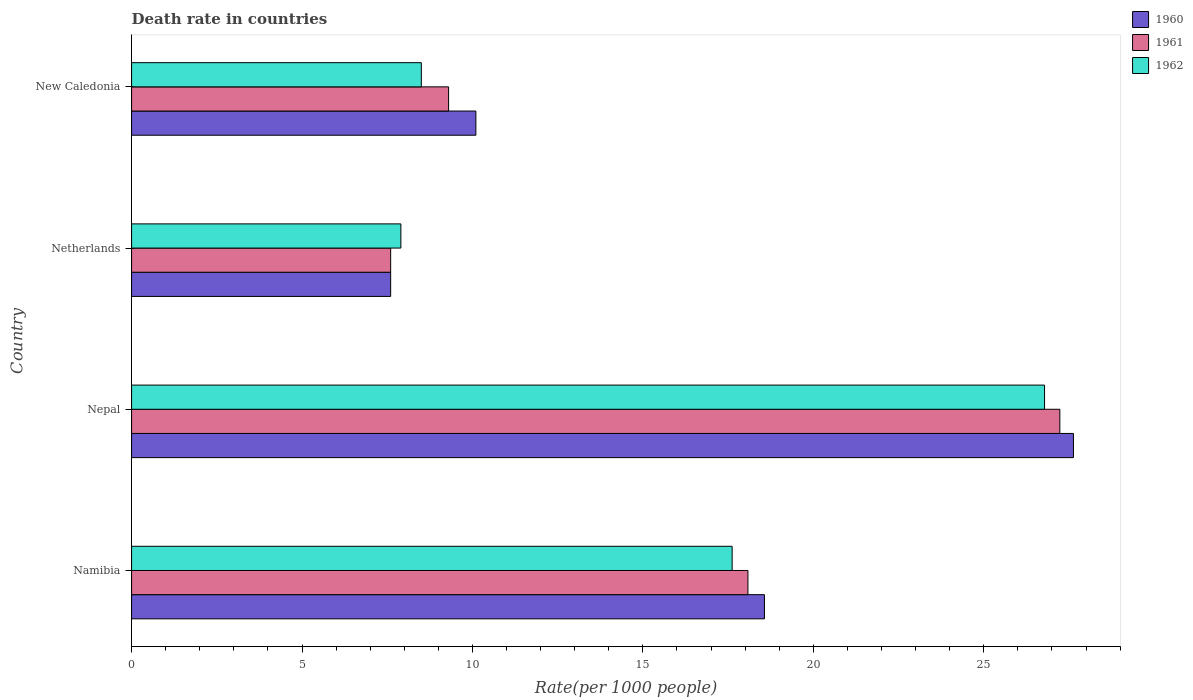How many different coloured bars are there?
Offer a very short reply. 3. How many groups of bars are there?
Your answer should be compact. 4. Are the number of bars per tick equal to the number of legend labels?
Offer a terse response. Yes. Are the number of bars on each tick of the Y-axis equal?
Provide a short and direct response. Yes. How many bars are there on the 1st tick from the bottom?
Make the answer very short. 3. What is the label of the 4th group of bars from the top?
Offer a very short reply. Namibia. In how many cases, is the number of bars for a given country not equal to the number of legend labels?
Offer a terse response. 0. What is the death rate in 1960 in Nepal?
Ensure brevity in your answer.  27.63. Across all countries, what is the maximum death rate in 1962?
Keep it short and to the point. 26.78. Across all countries, what is the minimum death rate in 1961?
Your answer should be compact. 7.6. In which country was the death rate in 1961 maximum?
Offer a terse response. Nepal. What is the total death rate in 1961 in the graph?
Provide a short and direct response. 62.21. What is the difference between the death rate in 1961 in Nepal and that in New Caledonia?
Offer a very short reply. 17.93. What is the difference between the death rate in 1962 in Netherlands and the death rate in 1960 in New Caledonia?
Provide a succinct answer. -2.2. What is the average death rate in 1962 per country?
Make the answer very short. 15.2. What is the difference between the death rate in 1961 and death rate in 1962 in Namibia?
Your answer should be very brief. 0.46. In how many countries, is the death rate in 1962 greater than 24 ?
Your answer should be compact. 1. What is the ratio of the death rate in 1962 in Nepal to that in Netherlands?
Your answer should be very brief. 3.39. Is the death rate in 1960 in Namibia less than that in Netherlands?
Your response must be concise. No. What is the difference between the highest and the second highest death rate in 1961?
Provide a short and direct response. 9.15. What is the difference between the highest and the lowest death rate in 1960?
Provide a succinct answer. 20.03. In how many countries, is the death rate in 1962 greater than the average death rate in 1962 taken over all countries?
Your answer should be very brief. 2. What does the 1st bar from the top in Nepal represents?
Your answer should be compact. 1962. Is it the case that in every country, the sum of the death rate in 1962 and death rate in 1961 is greater than the death rate in 1960?
Make the answer very short. Yes. Are all the bars in the graph horizontal?
Provide a short and direct response. Yes. What is the title of the graph?
Give a very brief answer. Death rate in countries. What is the label or title of the X-axis?
Keep it short and to the point. Rate(per 1000 people). What is the label or title of the Y-axis?
Your answer should be very brief. Country. What is the Rate(per 1000 people) of 1960 in Namibia?
Provide a short and direct response. 18.57. What is the Rate(per 1000 people) of 1961 in Namibia?
Your answer should be compact. 18.08. What is the Rate(per 1000 people) of 1962 in Namibia?
Keep it short and to the point. 17.62. What is the Rate(per 1000 people) of 1960 in Nepal?
Give a very brief answer. 27.63. What is the Rate(per 1000 people) in 1961 in Nepal?
Provide a short and direct response. 27.23. What is the Rate(per 1000 people) of 1962 in Nepal?
Keep it short and to the point. 26.78. What is the Rate(per 1000 people) in 1960 in Netherlands?
Provide a succinct answer. 7.6. What is the Rate(per 1000 people) in 1961 in Netherlands?
Offer a terse response. 7.6. What is the Rate(per 1000 people) in 1961 in New Caledonia?
Your response must be concise. 9.3. Across all countries, what is the maximum Rate(per 1000 people) in 1960?
Give a very brief answer. 27.63. Across all countries, what is the maximum Rate(per 1000 people) in 1961?
Your response must be concise. 27.23. Across all countries, what is the maximum Rate(per 1000 people) in 1962?
Your answer should be very brief. 26.78. Across all countries, what is the minimum Rate(per 1000 people) of 1962?
Your answer should be compact. 7.9. What is the total Rate(per 1000 people) of 1960 in the graph?
Offer a terse response. 63.9. What is the total Rate(per 1000 people) of 1961 in the graph?
Provide a succinct answer. 62.21. What is the total Rate(per 1000 people) in 1962 in the graph?
Give a very brief answer. 60.8. What is the difference between the Rate(per 1000 people) in 1960 in Namibia and that in Nepal?
Keep it short and to the point. -9.06. What is the difference between the Rate(per 1000 people) in 1961 in Namibia and that in Nepal?
Your response must be concise. -9.15. What is the difference between the Rate(per 1000 people) of 1962 in Namibia and that in Nepal?
Your answer should be very brief. -9.16. What is the difference between the Rate(per 1000 people) in 1960 in Namibia and that in Netherlands?
Offer a terse response. 10.97. What is the difference between the Rate(per 1000 people) in 1961 in Namibia and that in Netherlands?
Give a very brief answer. 10.48. What is the difference between the Rate(per 1000 people) in 1962 in Namibia and that in Netherlands?
Your answer should be compact. 9.72. What is the difference between the Rate(per 1000 people) in 1960 in Namibia and that in New Caledonia?
Keep it short and to the point. 8.47. What is the difference between the Rate(per 1000 people) of 1961 in Namibia and that in New Caledonia?
Give a very brief answer. 8.78. What is the difference between the Rate(per 1000 people) of 1962 in Namibia and that in New Caledonia?
Your answer should be very brief. 9.12. What is the difference between the Rate(per 1000 people) of 1960 in Nepal and that in Netherlands?
Keep it short and to the point. 20.03. What is the difference between the Rate(per 1000 people) of 1961 in Nepal and that in Netherlands?
Make the answer very short. 19.63. What is the difference between the Rate(per 1000 people) of 1962 in Nepal and that in Netherlands?
Provide a short and direct response. 18.88. What is the difference between the Rate(per 1000 people) in 1960 in Nepal and that in New Caledonia?
Provide a succinct answer. 17.53. What is the difference between the Rate(per 1000 people) of 1961 in Nepal and that in New Caledonia?
Your answer should be very brief. 17.93. What is the difference between the Rate(per 1000 people) of 1962 in Nepal and that in New Caledonia?
Your response must be concise. 18.28. What is the difference between the Rate(per 1000 people) in 1962 in Netherlands and that in New Caledonia?
Offer a very short reply. -0.6. What is the difference between the Rate(per 1000 people) in 1960 in Namibia and the Rate(per 1000 people) in 1961 in Nepal?
Your answer should be very brief. -8.66. What is the difference between the Rate(per 1000 people) in 1960 in Namibia and the Rate(per 1000 people) in 1962 in Nepal?
Keep it short and to the point. -8.22. What is the difference between the Rate(per 1000 people) in 1961 in Namibia and the Rate(per 1000 people) in 1962 in Nepal?
Give a very brief answer. -8.7. What is the difference between the Rate(per 1000 people) of 1960 in Namibia and the Rate(per 1000 people) of 1961 in Netherlands?
Your answer should be compact. 10.97. What is the difference between the Rate(per 1000 people) in 1960 in Namibia and the Rate(per 1000 people) in 1962 in Netherlands?
Offer a terse response. 10.67. What is the difference between the Rate(per 1000 people) in 1961 in Namibia and the Rate(per 1000 people) in 1962 in Netherlands?
Ensure brevity in your answer.  10.18. What is the difference between the Rate(per 1000 people) of 1960 in Namibia and the Rate(per 1000 people) of 1961 in New Caledonia?
Make the answer very short. 9.27. What is the difference between the Rate(per 1000 people) in 1960 in Namibia and the Rate(per 1000 people) in 1962 in New Caledonia?
Ensure brevity in your answer.  10.07. What is the difference between the Rate(per 1000 people) in 1961 in Namibia and the Rate(per 1000 people) in 1962 in New Caledonia?
Your answer should be very brief. 9.58. What is the difference between the Rate(per 1000 people) of 1960 in Nepal and the Rate(per 1000 people) of 1961 in Netherlands?
Provide a short and direct response. 20.03. What is the difference between the Rate(per 1000 people) of 1960 in Nepal and the Rate(per 1000 people) of 1962 in Netherlands?
Your answer should be compact. 19.73. What is the difference between the Rate(per 1000 people) of 1961 in Nepal and the Rate(per 1000 people) of 1962 in Netherlands?
Provide a succinct answer. 19.33. What is the difference between the Rate(per 1000 people) in 1960 in Nepal and the Rate(per 1000 people) in 1961 in New Caledonia?
Your answer should be compact. 18.33. What is the difference between the Rate(per 1000 people) in 1960 in Nepal and the Rate(per 1000 people) in 1962 in New Caledonia?
Provide a succinct answer. 19.13. What is the difference between the Rate(per 1000 people) of 1961 in Nepal and the Rate(per 1000 people) of 1962 in New Caledonia?
Your answer should be compact. 18.73. What is the difference between the Rate(per 1000 people) in 1960 in Netherlands and the Rate(per 1000 people) in 1961 in New Caledonia?
Provide a succinct answer. -1.7. What is the difference between the Rate(per 1000 people) in 1961 in Netherlands and the Rate(per 1000 people) in 1962 in New Caledonia?
Your response must be concise. -0.9. What is the average Rate(per 1000 people) of 1960 per country?
Give a very brief answer. 15.97. What is the average Rate(per 1000 people) in 1961 per country?
Offer a terse response. 15.55. What is the average Rate(per 1000 people) of 1962 per country?
Ensure brevity in your answer.  15.2. What is the difference between the Rate(per 1000 people) of 1960 and Rate(per 1000 people) of 1961 in Namibia?
Offer a very short reply. 0.48. What is the difference between the Rate(per 1000 people) of 1960 and Rate(per 1000 people) of 1962 in Namibia?
Keep it short and to the point. 0.95. What is the difference between the Rate(per 1000 people) in 1961 and Rate(per 1000 people) in 1962 in Namibia?
Your response must be concise. 0.46. What is the difference between the Rate(per 1000 people) in 1960 and Rate(per 1000 people) in 1962 in Nepal?
Your answer should be compact. 0.85. What is the difference between the Rate(per 1000 people) in 1961 and Rate(per 1000 people) in 1962 in Nepal?
Ensure brevity in your answer.  0.45. What is the difference between the Rate(per 1000 people) of 1960 and Rate(per 1000 people) of 1961 in Netherlands?
Offer a very short reply. 0. What is the difference between the Rate(per 1000 people) in 1961 and Rate(per 1000 people) in 1962 in Netherlands?
Give a very brief answer. -0.3. What is the difference between the Rate(per 1000 people) in 1961 and Rate(per 1000 people) in 1962 in New Caledonia?
Your answer should be very brief. 0.8. What is the ratio of the Rate(per 1000 people) of 1960 in Namibia to that in Nepal?
Give a very brief answer. 0.67. What is the ratio of the Rate(per 1000 people) in 1961 in Namibia to that in Nepal?
Your answer should be compact. 0.66. What is the ratio of the Rate(per 1000 people) in 1962 in Namibia to that in Nepal?
Provide a succinct answer. 0.66. What is the ratio of the Rate(per 1000 people) of 1960 in Namibia to that in Netherlands?
Give a very brief answer. 2.44. What is the ratio of the Rate(per 1000 people) of 1961 in Namibia to that in Netherlands?
Provide a succinct answer. 2.38. What is the ratio of the Rate(per 1000 people) in 1962 in Namibia to that in Netherlands?
Offer a very short reply. 2.23. What is the ratio of the Rate(per 1000 people) of 1960 in Namibia to that in New Caledonia?
Offer a very short reply. 1.84. What is the ratio of the Rate(per 1000 people) in 1961 in Namibia to that in New Caledonia?
Make the answer very short. 1.94. What is the ratio of the Rate(per 1000 people) in 1962 in Namibia to that in New Caledonia?
Your answer should be very brief. 2.07. What is the ratio of the Rate(per 1000 people) in 1960 in Nepal to that in Netherlands?
Provide a short and direct response. 3.64. What is the ratio of the Rate(per 1000 people) in 1961 in Nepal to that in Netherlands?
Provide a succinct answer. 3.58. What is the ratio of the Rate(per 1000 people) of 1962 in Nepal to that in Netherlands?
Provide a succinct answer. 3.39. What is the ratio of the Rate(per 1000 people) of 1960 in Nepal to that in New Caledonia?
Your answer should be compact. 2.74. What is the ratio of the Rate(per 1000 people) in 1961 in Nepal to that in New Caledonia?
Make the answer very short. 2.93. What is the ratio of the Rate(per 1000 people) of 1962 in Nepal to that in New Caledonia?
Offer a terse response. 3.15. What is the ratio of the Rate(per 1000 people) in 1960 in Netherlands to that in New Caledonia?
Your answer should be very brief. 0.75. What is the ratio of the Rate(per 1000 people) of 1961 in Netherlands to that in New Caledonia?
Ensure brevity in your answer.  0.82. What is the ratio of the Rate(per 1000 people) in 1962 in Netherlands to that in New Caledonia?
Provide a succinct answer. 0.93. What is the difference between the highest and the second highest Rate(per 1000 people) of 1960?
Make the answer very short. 9.06. What is the difference between the highest and the second highest Rate(per 1000 people) in 1961?
Make the answer very short. 9.15. What is the difference between the highest and the second highest Rate(per 1000 people) in 1962?
Your response must be concise. 9.16. What is the difference between the highest and the lowest Rate(per 1000 people) of 1960?
Provide a succinct answer. 20.03. What is the difference between the highest and the lowest Rate(per 1000 people) in 1961?
Make the answer very short. 19.63. What is the difference between the highest and the lowest Rate(per 1000 people) in 1962?
Ensure brevity in your answer.  18.88. 